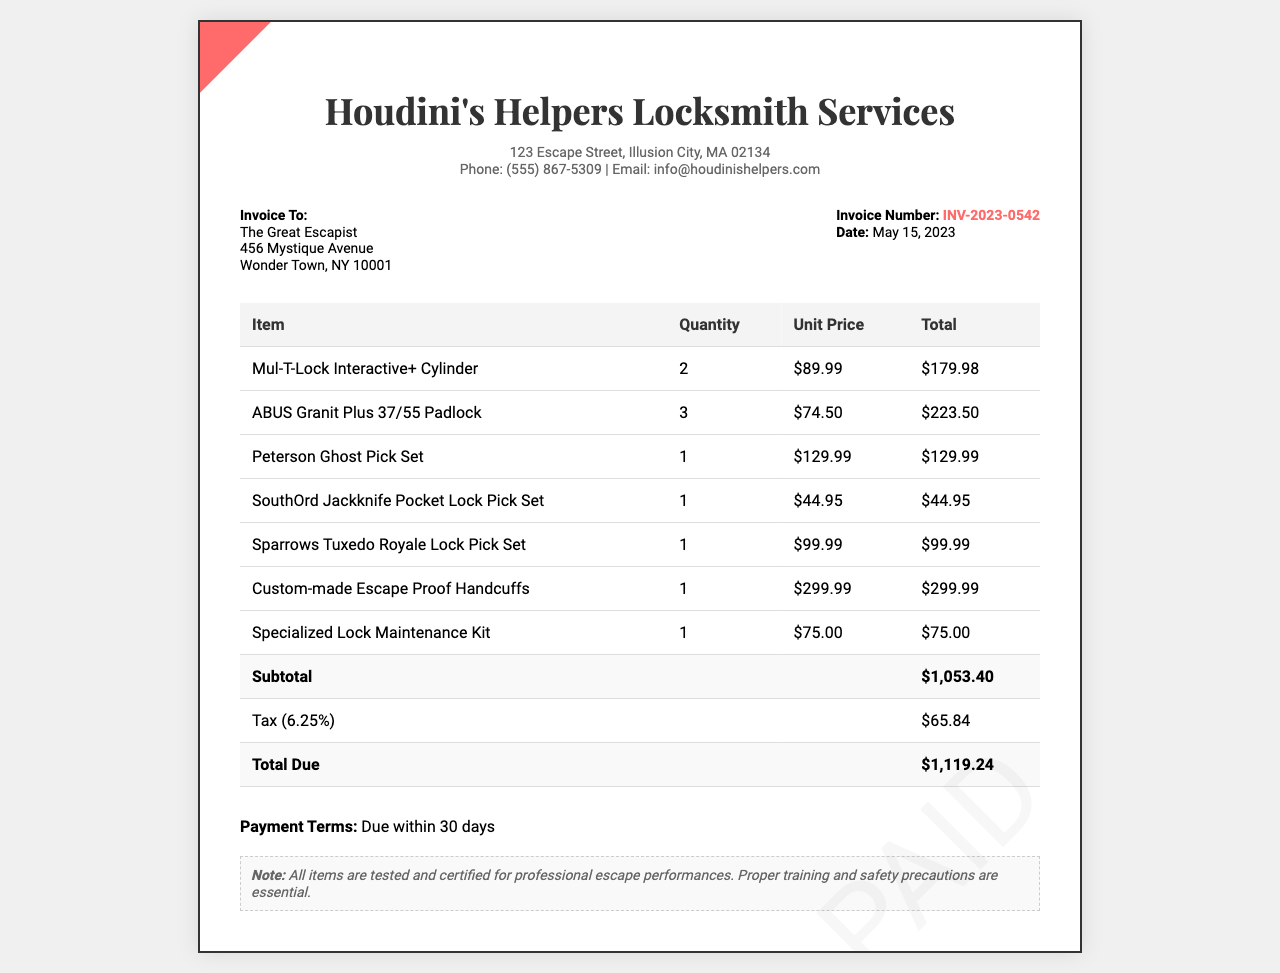What is the invoice number? The invoice number is a unique identifier for the invoice found in the document.
Answer: INV-2023-0542 What is the date of the invoice? The date indicates when the invoice was issued as stated in the document.
Answer: May 15, 2023 How many Mul-T-Lock Interactive+ Cylinders were purchased? This question seeks the quantity of a specific item listed in the invoice.
Answer: 2 What is the subtotal amount? The subtotal is the total of all items before tax is applied, which is provided in the document.
Answer: $1,053.40 What is the tax rate applied to the invoice? The tax rate reflects the percentage charged on the subtotal as described in the invoice.
Answer: 6.25% What is the total amount due? The total due is the final amount payable after adding the tax to the subtotal.
Answer: $1,119.24 Which company issued this invoice? The company name is presented prominently at the top of the invoice as the service provider.
Answer: Houdini's Helpers Locksmith Services Who is the invoice addressed to? The recipient of the invoice is mentioned with their name and address, asking for the customer.
Answer: The Great Escapist What item costs the most? The question asks for the item with the highest unit price as indicated in the invoice.
Answer: Custom-made Escape Proof Handcuffs 